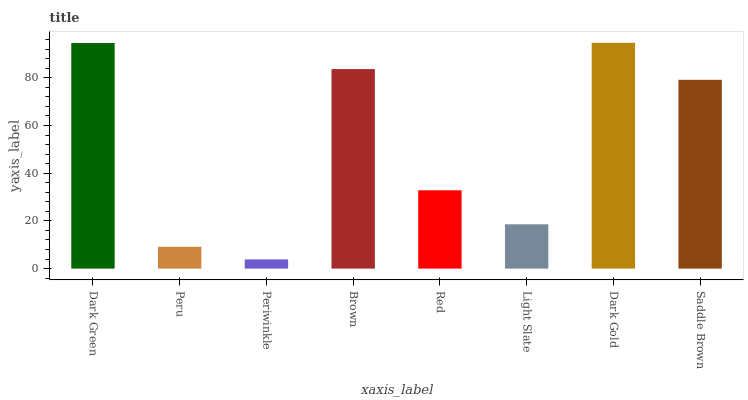Is Periwinkle the minimum?
Answer yes or no. Yes. Is Dark Gold the maximum?
Answer yes or no. Yes. Is Peru the minimum?
Answer yes or no. No. Is Peru the maximum?
Answer yes or no. No. Is Dark Green greater than Peru?
Answer yes or no. Yes. Is Peru less than Dark Green?
Answer yes or no. Yes. Is Peru greater than Dark Green?
Answer yes or no. No. Is Dark Green less than Peru?
Answer yes or no. No. Is Saddle Brown the high median?
Answer yes or no. Yes. Is Red the low median?
Answer yes or no. Yes. Is Red the high median?
Answer yes or no. No. Is Brown the low median?
Answer yes or no. No. 